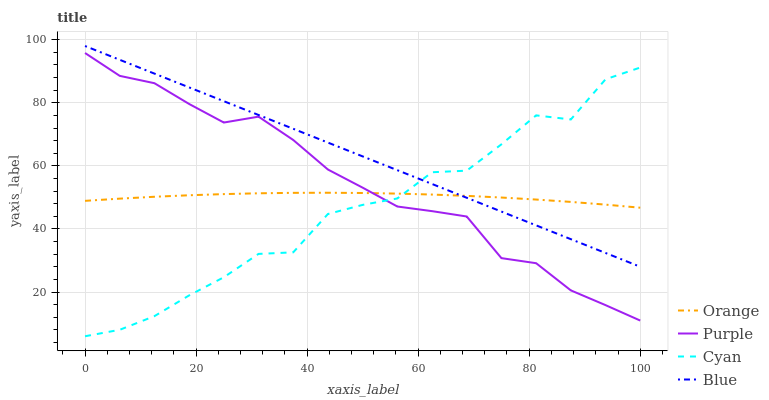Does Purple have the minimum area under the curve?
Answer yes or no. No. Does Purple have the maximum area under the curve?
Answer yes or no. No. Is Purple the smoothest?
Answer yes or no. No. Is Purple the roughest?
Answer yes or no. No. Does Purple have the lowest value?
Answer yes or no. No. Does Purple have the highest value?
Answer yes or no. No. Is Purple less than Blue?
Answer yes or no. Yes. Is Blue greater than Purple?
Answer yes or no. Yes. Does Purple intersect Blue?
Answer yes or no. No. 